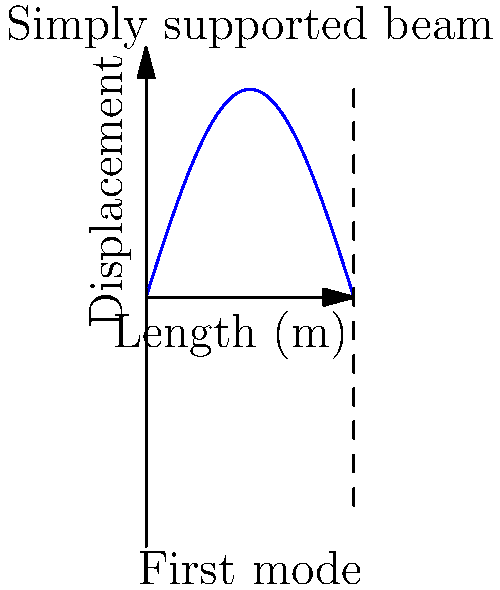As an epidemiologist studying the relationship between infrastructure and public health, you're analyzing the vibration characteristics of a bridge. The bridge can be modeled as a simply supported beam. Given that the first mode shape of the beam is represented by the function $y(x) = \sin(\frac{\pi x}{L})$, where $L$ is the length of the beam, what is the wavelength of this mode in terms of $L$? To find the wavelength of the first vibration mode, we can follow these steps:

1) The wavelength is the distance over which the wave's shape repeats.

2) For a simply supported beam, the first mode shape is a half-sine wave that fits exactly within the length of the beam.

3) The given function $y(x) = \sin(\frac{\pi x}{L})$ represents this half-sine wave.

4) We can see that when $x = L$, the argument of the sine function is $\pi$, which corresponds to half a complete sine wave.

5) Therefore, the length of the beam $L$ is equal to half of the wavelength.

6) If we denote the wavelength as $\lambda$, we can write:

   $L = \frac{1}{2}\lambda$

7) Solving for $\lambda$:

   $\lambda = 2L$

Thus, the wavelength of the first mode is twice the length of the beam.
Answer: $2L$ 